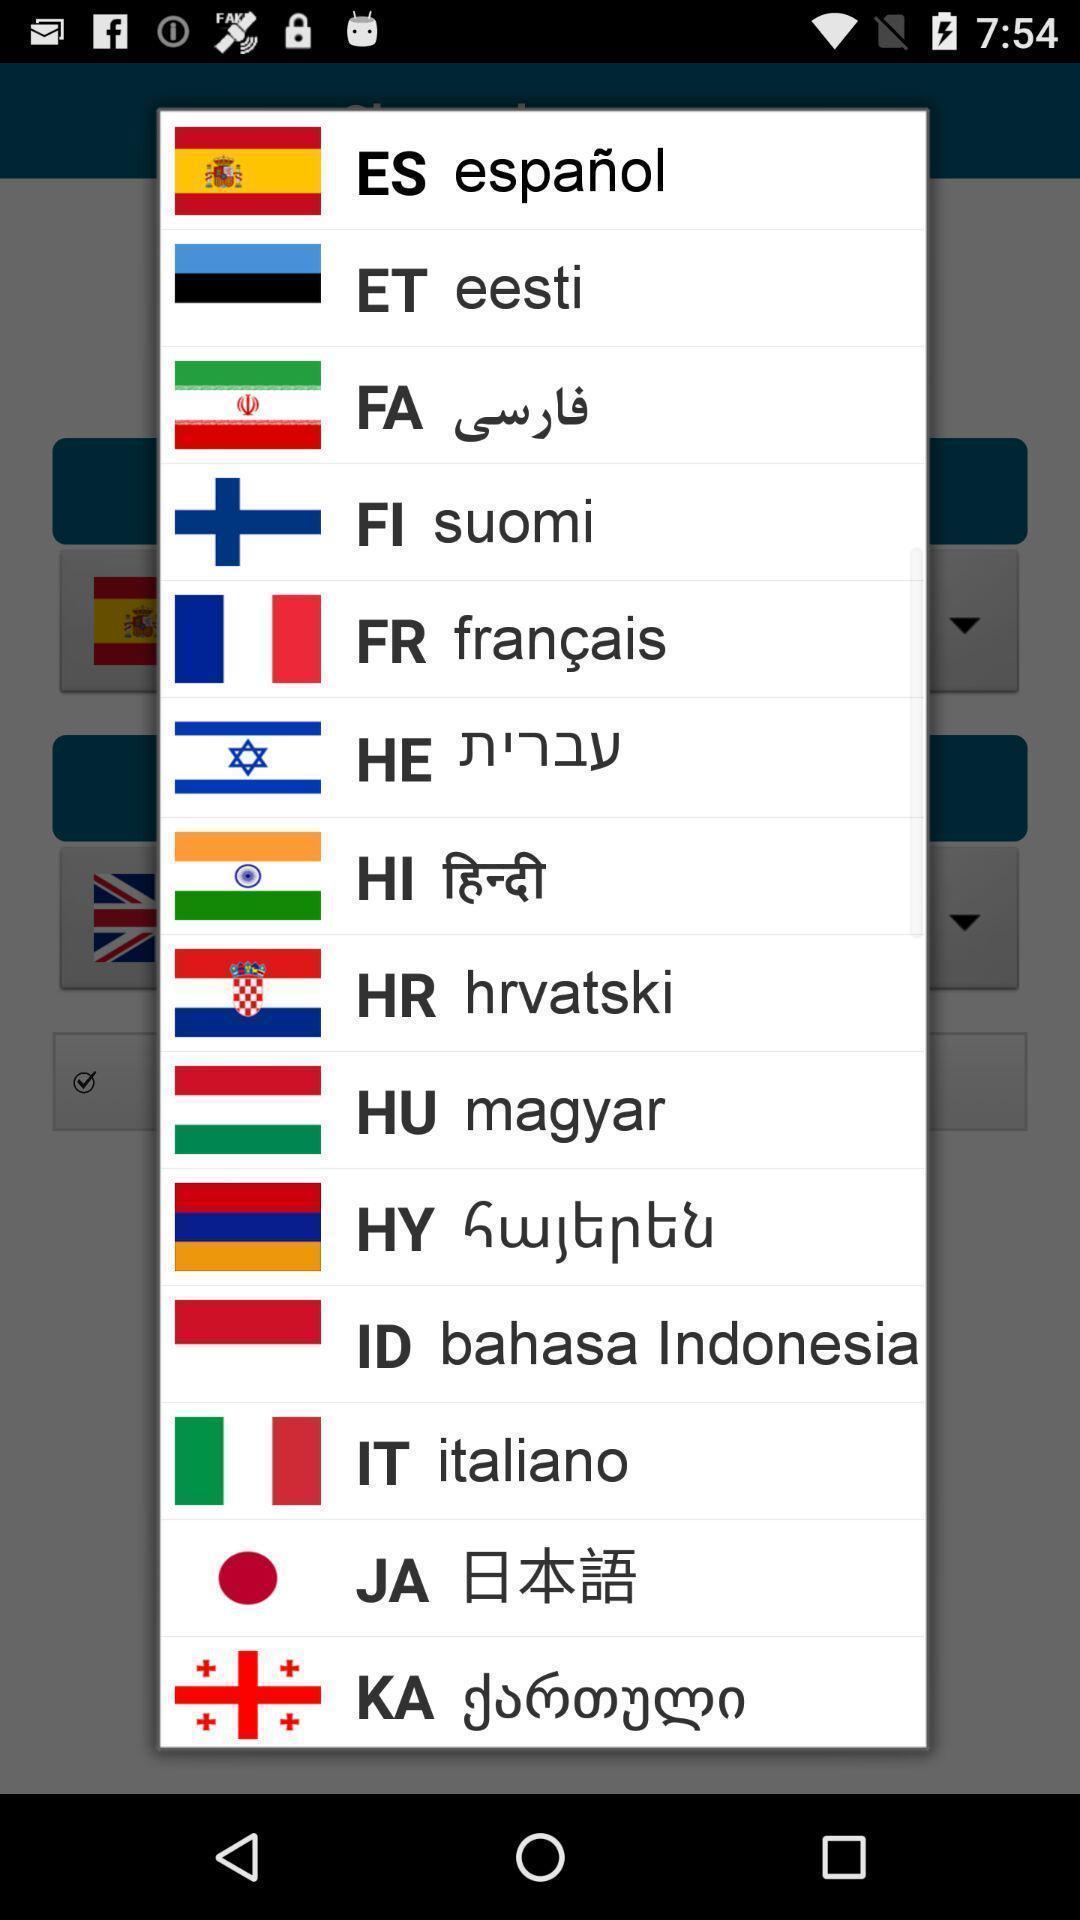Explain what's happening in this screen capture. Pop-up showing list of various languages. 